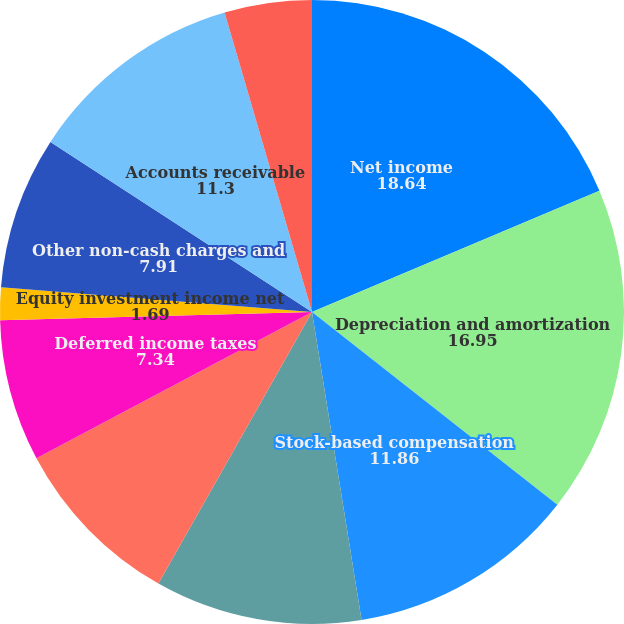Convert chart. <chart><loc_0><loc_0><loc_500><loc_500><pie_chart><fcel>Net income<fcel>Depreciation and amortization<fcel>Stock-based compensation<fcel>Tax benefits from stock award<fcel>Excess tax benefits from stock<fcel>Deferred income taxes<fcel>Equity investment income net<fcel>Other non-cash charges and<fcel>Accounts receivable<fcel>Inventories<nl><fcel>18.64%<fcel>16.95%<fcel>11.86%<fcel>10.73%<fcel>9.04%<fcel>7.34%<fcel>1.69%<fcel>7.91%<fcel>11.3%<fcel>4.52%<nl></chart> 